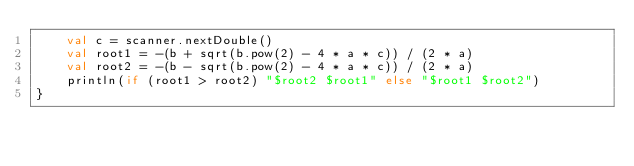<code> <loc_0><loc_0><loc_500><loc_500><_Kotlin_>    val c = scanner.nextDouble()
    val root1 = -(b + sqrt(b.pow(2) - 4 * a * c)) / (2 * a)
    val root2 = -(b - sqrt(b.pow(2) - 4 * a * c)) / (2 * a)
    println(if (root1 > root2) "$root2 $root1" else "$root1 $root2")
}</code> 